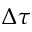<formula> <loc_0><loc_0><loc_500><loc_500>\Delta \tau</formula> 